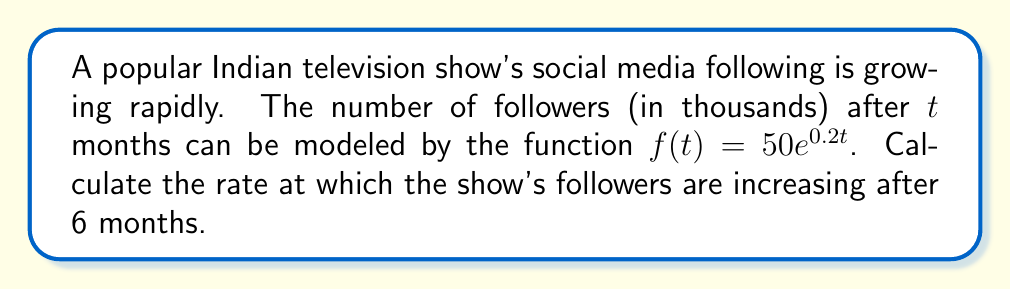Can you answer this question? To find the rate at which the show's followers are increasing after 6 months, we need to find the derivative of the function $f(t)$ and evaluate it at $t=6$.

Step 1: Find the derivative of $f(t)$
$$f(t) = 50e^{0.2t}$$
Using the chain rule, we get:
$$f'(t) = 50 \cdot 0.2 \cdot e^{0.2t} = 10e^{0.2t}$$

Step 2: Evaluate $f'(t)$ at $t=6$
$$f'(6) = 10e^{0.2 \cdot 6} = 10e^{1.2} \approx 33.12$$

Step 3: Interpret the result
The rate of change at $t=6$ is approximately 33.12 thousand followers per month.

To ensure a fair and balanced representation, it's important to note that this exponential growth model may not be sustainable in the long term, and the actual growth rate might vary due to various factors in the television industry.
Answer: $33.12$ thousand followers per month 